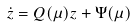Convert formula to latex. <formula><loc_0><loc_0><loc_500><loc_500>\dot { z } = Q ( \mu ) z + \Psi ( \mu )</formula> 